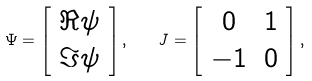<formula> <loc_0><loc_0><loc_500><loc_500>\Psi = \left [ \begin{array} { c } \Re \psi \\ \Im \psi \end{array} \right ] , \quad J = \left [ \begin{array} { c c } 0 & 1 \\ - 1 & 0 \end{array} \right ] ,</formula> 